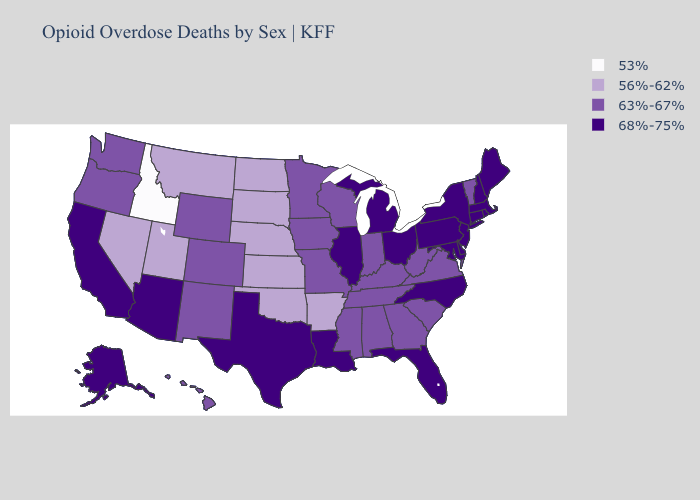Name the states that have a value in the range 63%-67%?
Concise answer only. Alabama, Colorado, Georgia, Hawaii, Indiana, Iowa, Kentucky, Minnesota, Mississippi, Missouri, New Mexico, Oregon, South Carolina, Tennessee, Vermont, Virginia, Washington, West Virginia, Wisconsin, Wyoming. What is the value of Louisiana?
Short answer required. 68%-75%. What is the highest value in the Northeast ?
Be succinct. 68%-75%. Name the states that have a value in the range 56%-62%?
Concise answer only. Arkansas, Kansas, Montana, Nebraska, Nevada, North Dakota, Oklahoma, South Dakota, Utah. Name the states that have a value in the range 53%?
Concise answer only. Idaho. Name the states that have a value in the range 68%-75%?
Give a very brief answer. Alaska, Arizona, California, Connecticut, Delaware, Florida, Illinois, Louisiana, Maine, Maryland, Massachusetts, Michigan, New Hampshire, New Jersey, New York, North Carolina, Ohio, Pennsylvania, Rhode Island, Texas. Does the first symbol in the legend represent the smallest category?
Quick response, please. Yes. What is the highest value in states that border Washington?
Short answer required. 63%-67%. Does Ohio have the lowest value in the MidWest?
Be succinct. No. Name the states that have a value in the range 68%-75%?
Answer briefly. Alaska, Arizona, California, Connecticut, Delaware, Florida, Illinois, Louisiana, Maine, Maryland, Massachusetts, Michigan, New Hampshire, New Jersey, New York, North Carolina, Ohio, Pennsylvania, Rhode Island, Texas. What is the lowest value in states that border North Dakota?
Short answer required. 56%-62%. Name the states that have a value in the range 63%-67%?
Answer briefly. Alabama, Colorado, Georgia, Hawaii, Indiana, Iowa, Kentucky, Minnesota, Mississippi, Missouri, New Mexico, Oregon, South Carolina, Tennessee, Vermont, Virginia, Washington, West Virginia, Wisconsin, Wyoming. What is the value of Connecticut?
Quick response, please. 68%-75%. Name the states that have a value in the range 53%?
Quick response, please. Idaho. Does the map have missing data?
Concise answer only. No. 